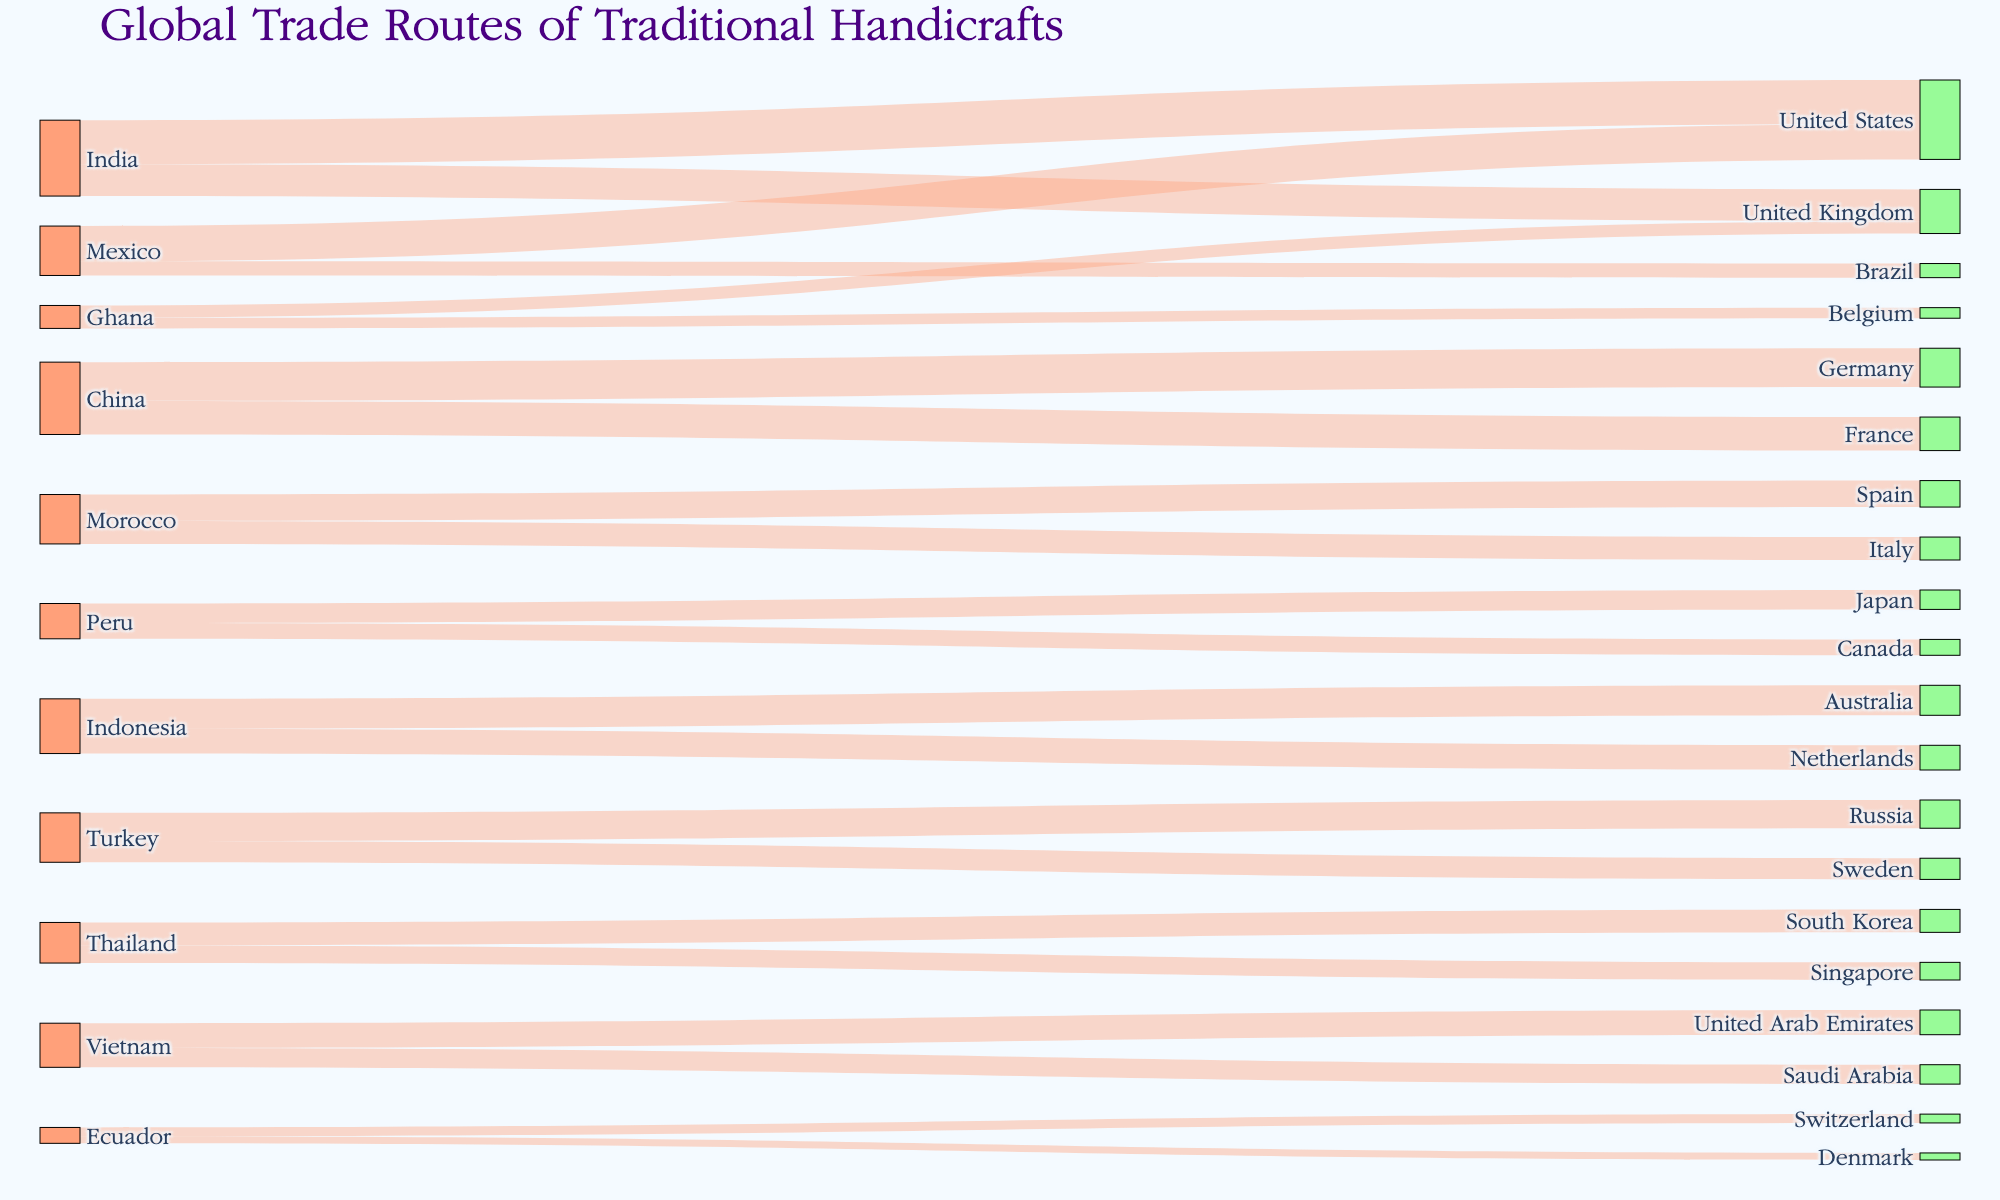How many unique countries are exporting traditional handicrafts? The number of unique countries can be found by counting all the distinct source nodes in the Sankey diagram. There are 10 unique source nodes: India, China, Morocco, Peru, Indonesia, Turkey, Mexico, Thailand, Vietnam, and Ghana.
Answer: 10 Which country exports the most traditional handicrafts to the United States? The value of handicrafts exported to the United States can be compared among the countries exporting there. From the value data, India exports 250 units to the United States, while Mexico exports 200 units. Thus, India exports the most.
Answer: India What is the total value of traditional handicrafts exported from China? The total value can be calculated by summing the export values from China to all destination markets. China exports 220 units to Germany and 190 units to France. So, the total is 220 + 190 = 410.
Answer: 410 How many destination markets receive traditional handicrafts from Thailand? The number of destination markets can be found by counting all the target nodes that have Thailand as their source. Thailand exports to two destinations: South Korea (130 units) and Singapore (100 units).
Answer: 2 Which country has the lowest total export value among the listed countries? To find the country with the lowest total export value, sum the export values for each country and compare. Ecuador exports 50 units to Switzerland and 40 units to Denmark, totalling 90 units, which is the lowest among the listed countries.
Answer: Ecuador Compare the export values of traditional handicrafts from Morocco and Peru. Which country has the higher combined export value? Sum the export values for Morocco and Peru. Morocco exports 150 units to Spain and 130 units to Italy, totalling 280 units. Peru exports 110 units to Japan and 90 units to Canada, totalling 200 units. Therefore, Morocco has a higher combined export value.
Answer: Morocco What is the total value of traditional handicrafts exported to the United Kingdom? The total value can be calculated by summing the values exported to the United Kingdom from all sources. India exports 180 units, and Ghana exports 70 units to the United Kingdom. So, the total is 180 + 70 = 250.
Answer: 250 Identify the destination market with the highest import value of traditional handicrafts from Vietnam. Compare the values of handicrafts exported from Vietnam to different markets. Vietnam exports 140 units to the United Arab Emirates and 110 units to Saudi Arabia. The United Arab Emirates receives the highest value.
Answer: United Arab Emirates What is the total value of traditional handicrafts traded globally according to the diagram? Sum all the export values from all sources to destination markets. The total is 250 + 180 + 220 + 190 + 150 + 130 + 110 + 90 + 170 + 140 + 160 + 120 + 200 + 80 + 130 + 100 + 140 + 110 + 70 + 60 + 50 + 40 = 2890.
Answer: 2890 